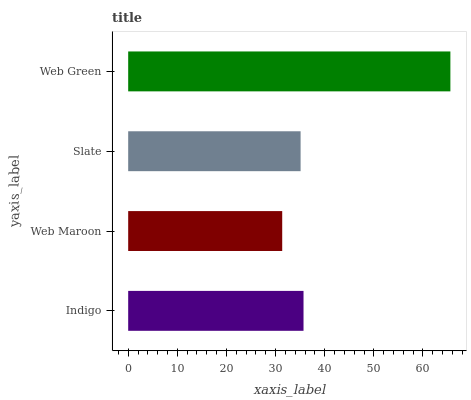Is Web Maroon the minimum?
Answer yes or no. Yes. Is Web Green the maximum?
Answer yes or no. Yes. Is Slate the minimum?
Answer yes or no. No. Is Slate the maximum?
Answer yes or no. No. Is Slate greater than Web Maroon?
Answer yes or no. Yes. Is Web Maroon less than Slate?
Answer yes or no. Yes. Is Web Maroon greater than Slate?
Answer yes or no. No. Is Slate less than Web Maroon?
Answer yes or no. No. Is Indigo the high median?
Answer yes or no. Yes. Is Slate the low median?
Answer yes or no. Yes. Is Slate the high median?
Answer yes or no. No. Is Web Green the low median?
Answer yes or no. No. 